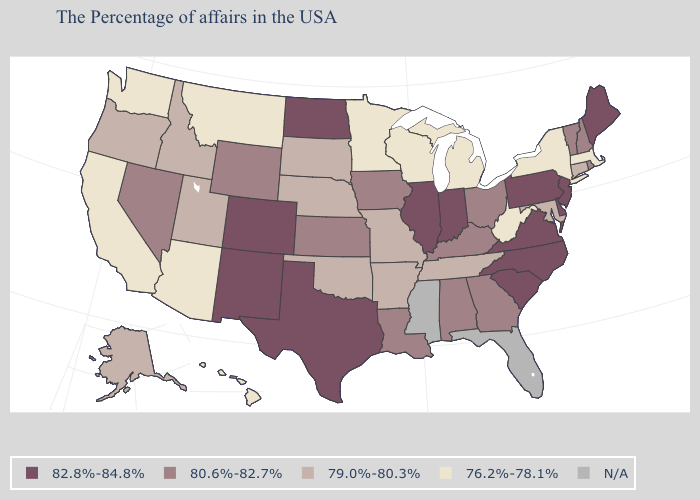Name the states that have a value in the range 82.8%-84.8%?
Keep it brief. Maine, New Jersey, Delaware, Pennsylvania, Virginia, North Carolina, South Carolina, Indiana, Illinois, Texas, North Dakota, Colorado, New Mexico. Among the states that border Wisconsin , which have the highest value?
Answer briefly. Illinois. Name the states that have a value in the range N/A?
Write a very short answer. Florida, Mississippi. Among the states that border New York , which have the lowest value?
Be succinct. Massachusetts. What is the value of Montana?
Concise answer only. 76.2%-78.1%. What is the value of North Carolina?
Be succinct. 82.8%-84.8%. Does Georgia have the lowest value in the USA?
Concise answer only. No. What is the lowest value in the South?
Concise answer only. 76.2%-78.1%. Name the states that have a value in the range 79.0%-80.3%?
Keep it brief. Connecticut, Maryland, Tennessee, Missouri, Arkansas, Nebraska, Oklahoma, South Dakota, Utah, Idaho, Oregon, Alaska. What is the value of Arkansas?
Write a very short answer. 79.0%-80.3%. What is the lowest value in the West?
Short answer required. 76.2%-78.1%. What is the value of South Dakota?
Be succinct. 79.0%-80.3%. Does Georgia have the lowest value in the USA?
Concise answer only. No. What is the value of Connecticut?
Give a very brief answer. 79.0%-80.3%. What is the highest value in states that border Alabama?
Short answer required. 80.6%-82.7%. 